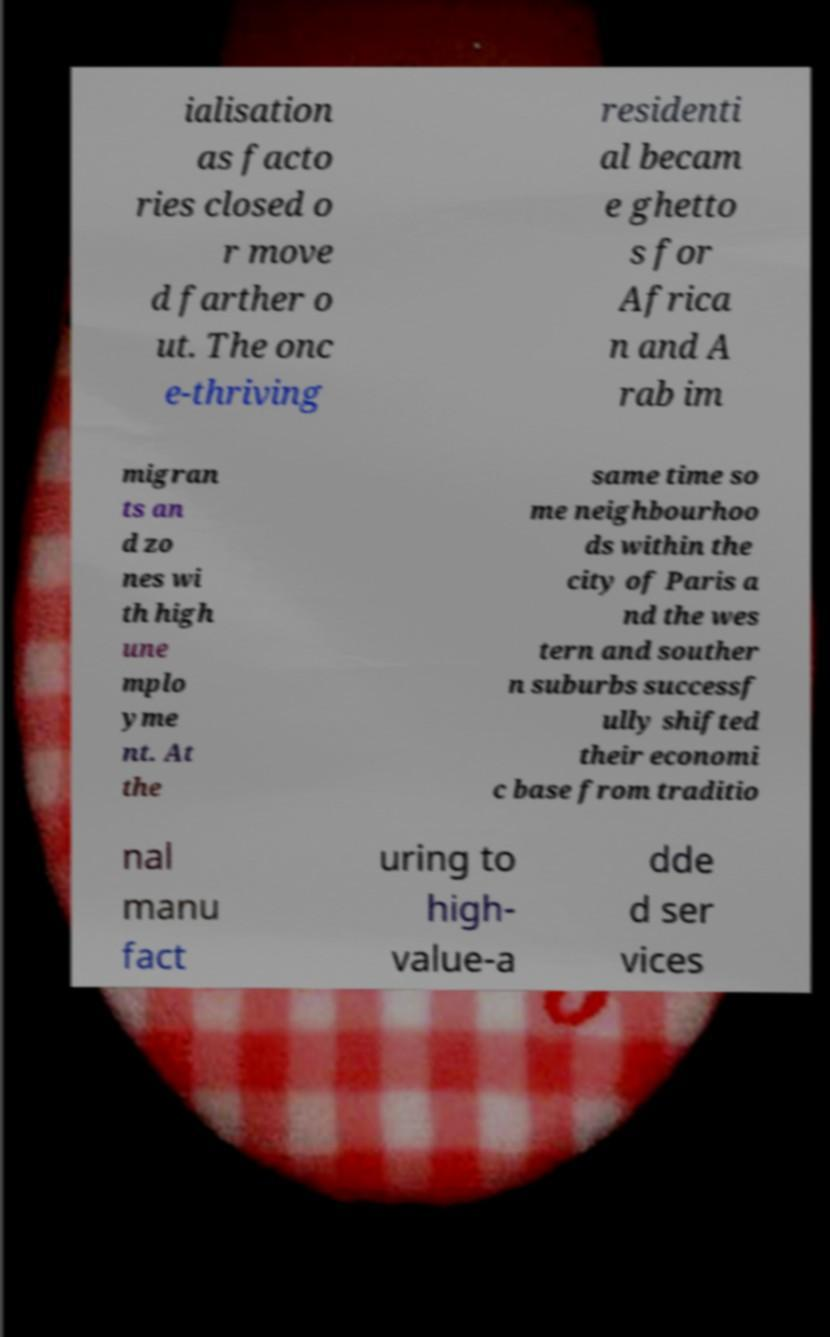Could you extract and type out the text from this image? ialisation as facto ries closed o r move d farther o ut. The onc e-thriving residenti al becam e ghetto s for Africa n and A rab im migran ts an d zo nes wi th high une mplo yme nt. At the same time so me neighbourhoo ds within the city of Paris a nd the wes tern and souther n suburbs successf ully shifted their economi c base from traditio nal manu fact uring to high- value-a dde d ser vices 